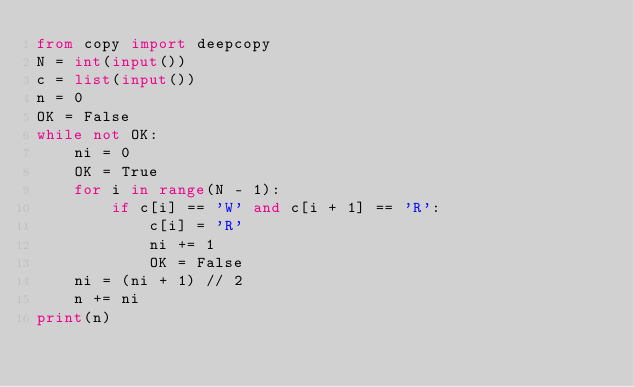Convert code to text. <code><loc_0><loc_0><loc_500><loc_500><_Python_>from copy import deepcopy
N = int(input())
c = list(input())
n = 0
OK = False
while not OK:
    ni = 0
    OK = True
    for i in range(N - 1):
        if c[i] == 'W' and c[i + 1] == 'R':
            c[i] = 'R'
            ni += 1
            OK = False
    ni = (ni + 1) // 2
    n += ni
print(n)</code> 